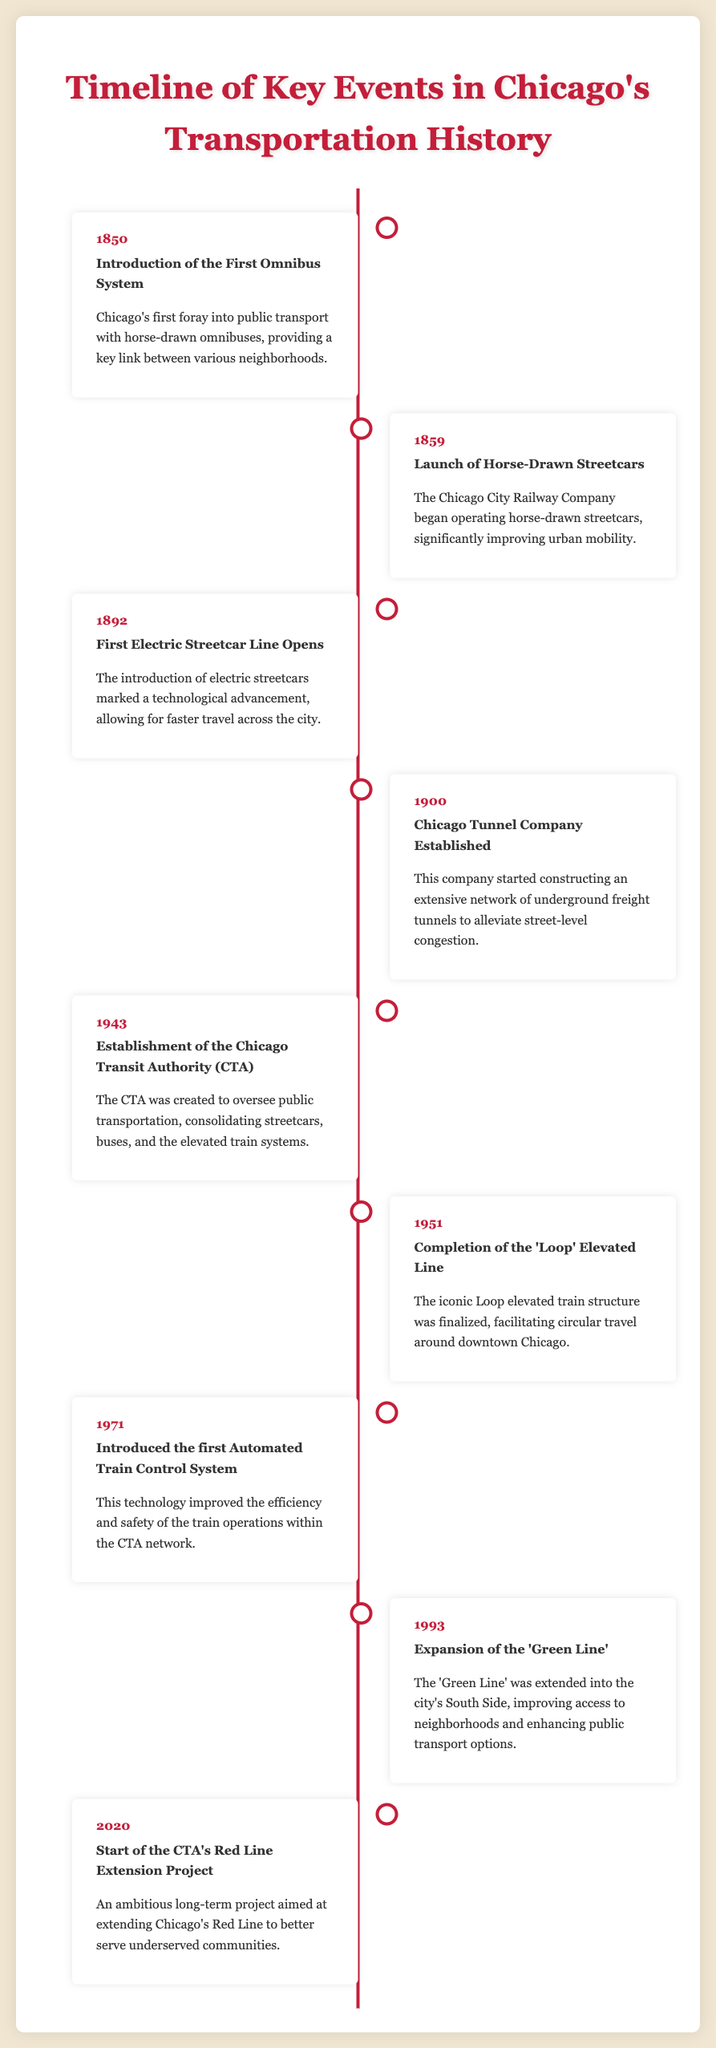What year was the first omnibus system introduced? The document provides a timeline where 1850 is mentioned as the year of the first omnibus system's introduction.
Answer: 1850 What transportation milestone occurred in 1892? The document states that in 1892, the first electric streetcar line opened in Chicago.
Answer: First Electric Streetcar Line Opens When was the Chicago Transit Authority (CTA) established? The timeline indicates that the CTA was established in 1943 to oversee public transportation.
Answer: 1943 What significant infrastructure was completed in 1951? The document notes that the completion of the 'Loop' elevated line occurred in 1951.
Answer: 'Loop' Elevated Line How many years apart were the introduction of horse-drawn streetcars and the first electric streetcar line? The document shows the streetcars were introduced in 1859 and the electric streetcar line in 1892, making it a 33-year gap.
Answer: 33 years What is the main goal of the CTA's Red Line Extension Project started in 2020? According to the timeline, the goal is to better serve underserved communities in Chicago.
Answer: Better serve underserved communities Which company started constructing an underground freight tunnel network? The document states that the Chicago Tunnel Company established a tunnel network in 1900.
Answer: Chicago Tunnel Company In which year was the first Automated Train Control System introduced? The timeline indicates that the first Automated Train Control System was introduced in 1971.
Answer: 1971 